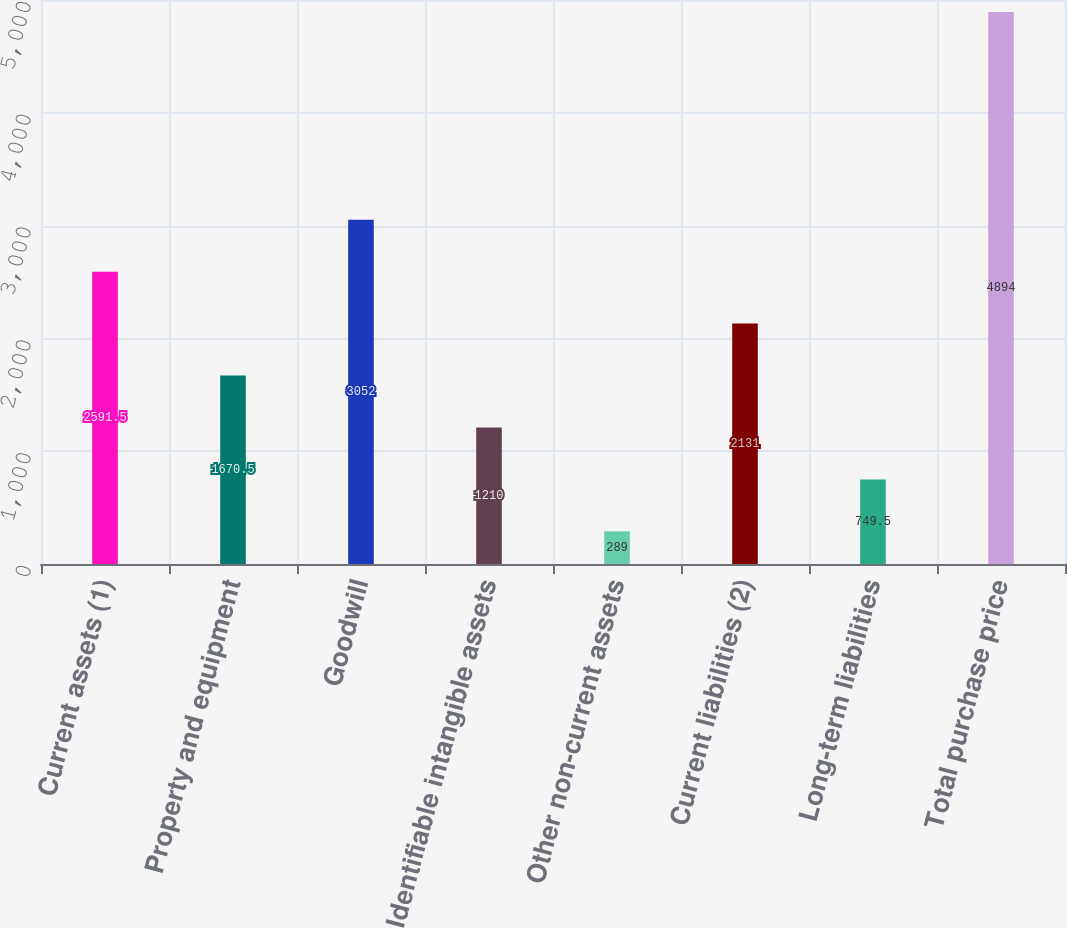Convert chart to OTSL. <chart><loc_0><loc_0><loc_500><loc_500><bar_chart><fcel>Current assets (1)<fcel>Property and equipment<fcel>Goodwill<fcel>Identifiable intangible assets<fcel>Other non-current assets<fcel>Current liabilities (2)<fcel>Long-term liabilities<fcel>Total purchase price<nl><fcel>2591.5<fcel>1670.5<fcel>3052<fcel>1210<fcel>289<fcel>2131<fcel>749.5<fcel>4894<nl></chart> 